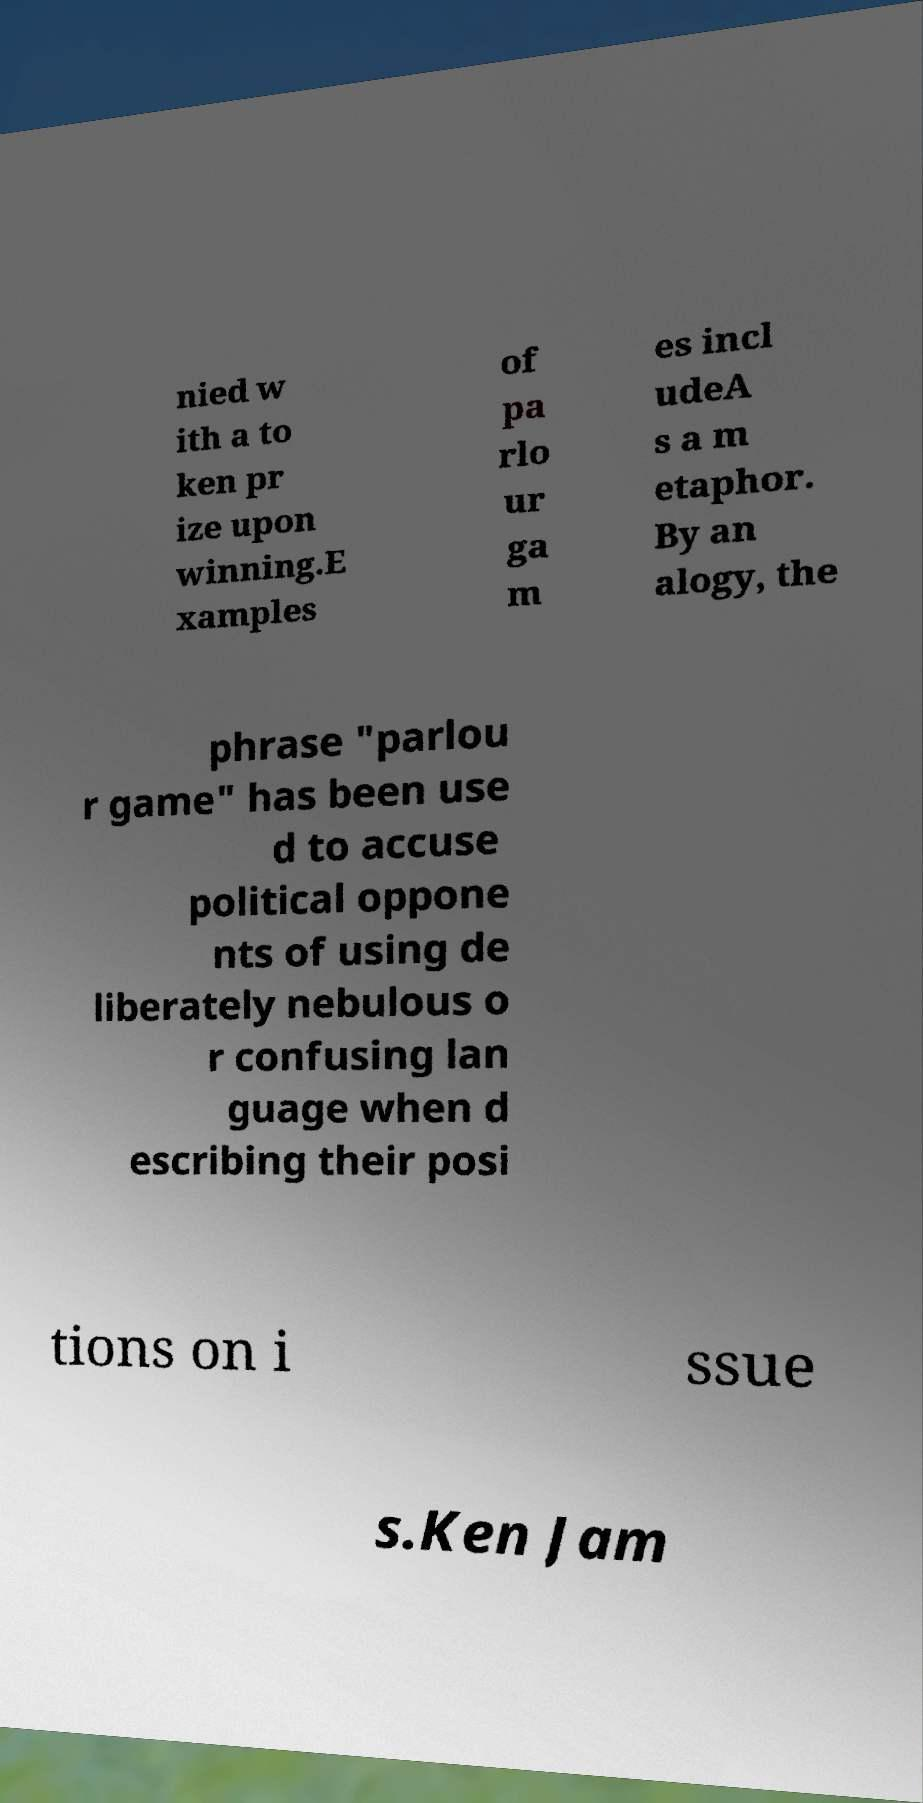Could you assist in decoding the text presented in this image and type it out clearly? nied w ith a to ken pr ize upon winning.E xamples of pa rlo ur ga m es incl udeA s a m etaphor. By an alogy, the phrase "parlou r game" has been use d to accuse political oppone nts of using de liberately nebulous o r confusing lan guage when d escribing their posi tions on i ssue s.Ken Jam 